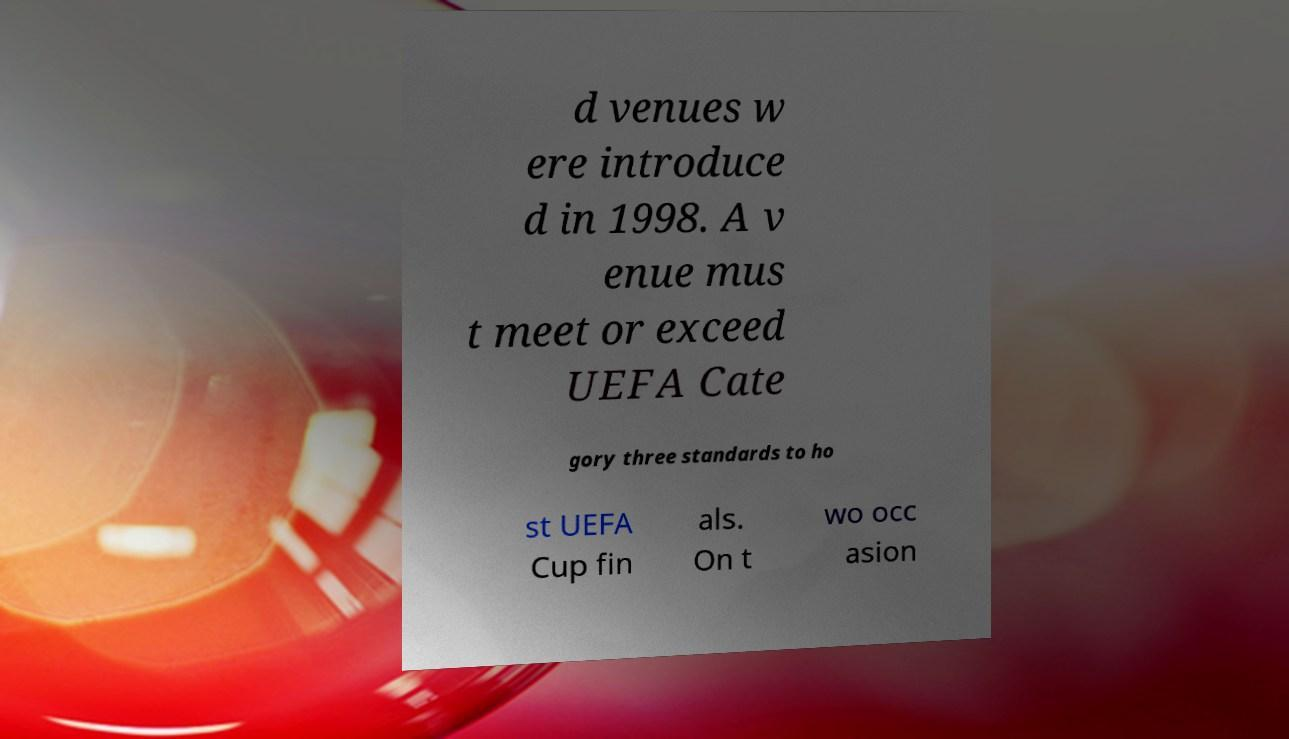Please read and relay the text visible in this image. What does it say? d venues w ere introduce d in 1998. A v enue mus t meet or exceed UEFA Cate gory three standards to ho st UEFA Cup fin als. On t wo occ asion 